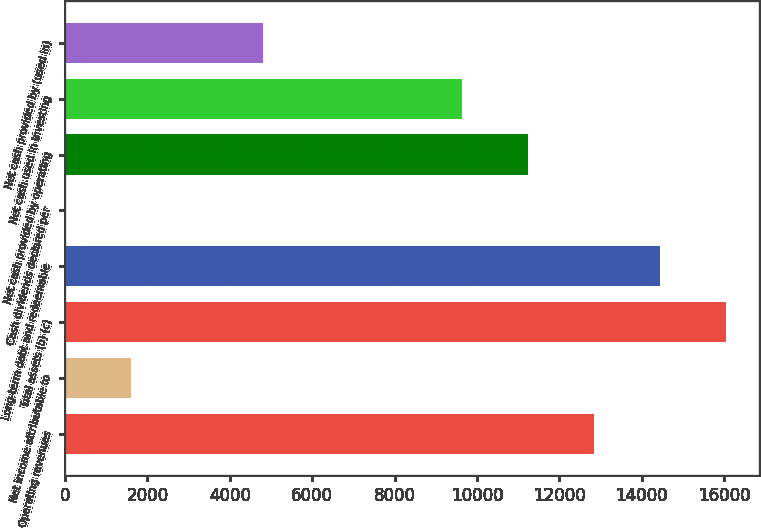Convert chart. <chart><loc_0><loc_0><loc_500><loc_500><bar_chart><fcel>Operating revenues<fcel>Net income attributable to<fcel>Total assets (b) (c)<fcel>Long-term debt and redeemable<fcel>Cash dividends declared per<fcel>Net cash provided by operating<fcel>Net cash used in investing<fcel>Net cash provided by (used in)<nl><fcel>12830.7<fcel>1604.92<fcel>16038<fcel>14434.4<fcel>1.24<fcel>11227<fcel>9623.32<fcel>4812.28<nl></chart> 